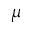<formula> <loc_0><loc_0><loc_500><loc_500>\mu</formula> 